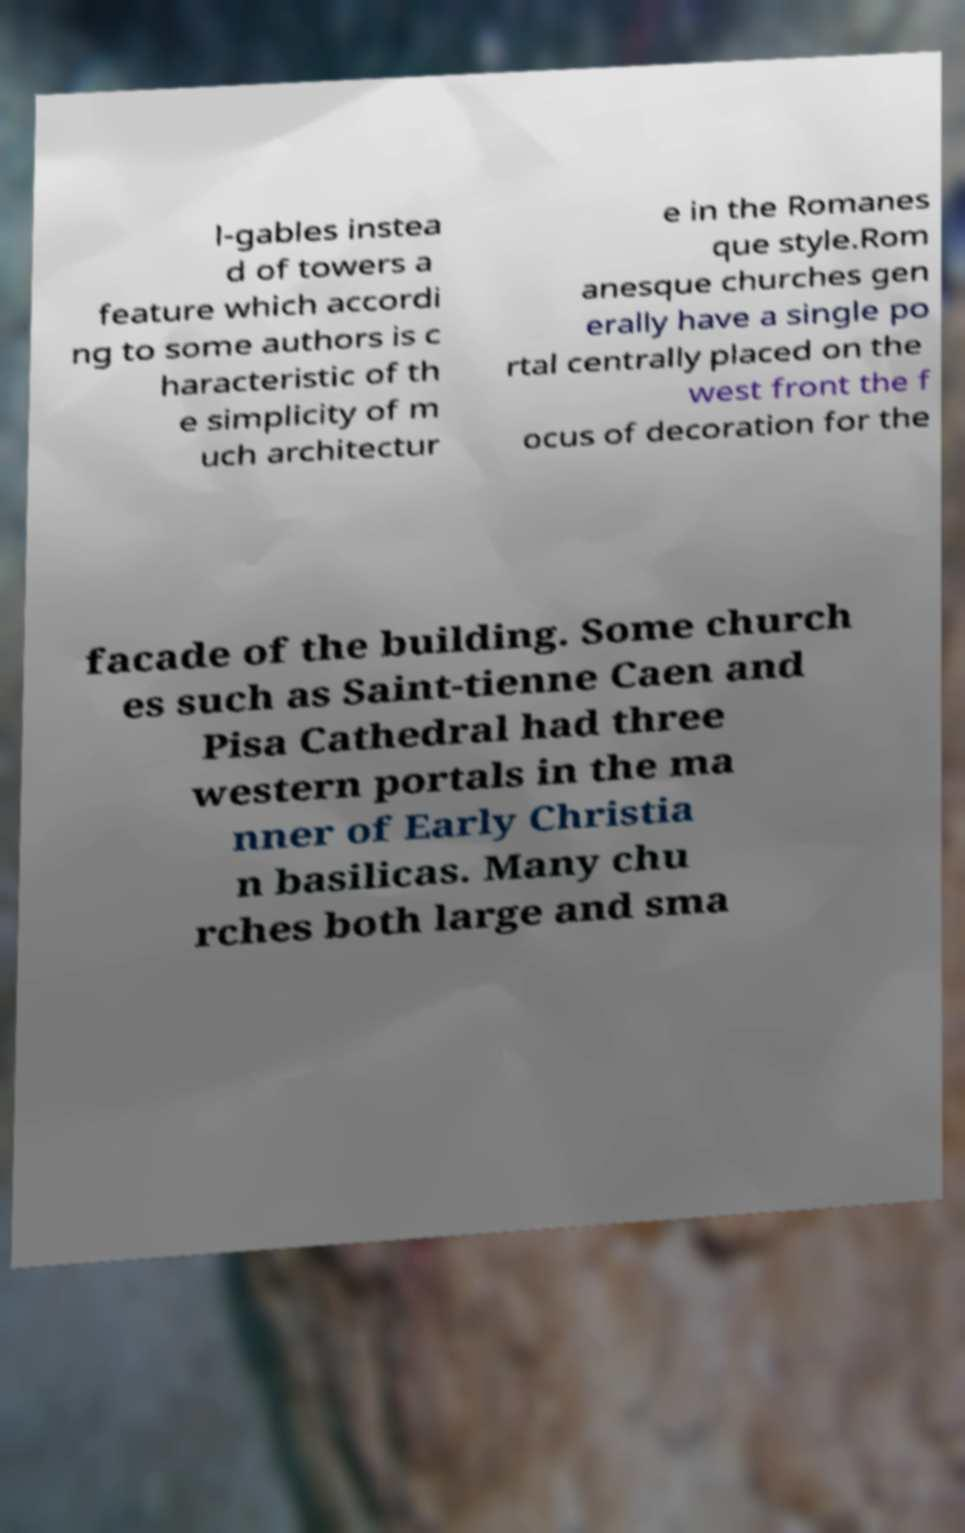Please identify and transcribe the text found in this image. l-gables instea d of towers a feature which accordi ng to some authors is c haracteristic of th e simplicity of m uch architectur e in the Romanes que style.Rom anesque churches gen erally have a single po rtal centrally placed on the west front the f ocus of decoration for the facade of the building. Some church es such as Saint-tienne Caen and Pisa Cathedral had three western portals in the ma nner of Early Christia n basilicas. Many chu rches both large and sma 